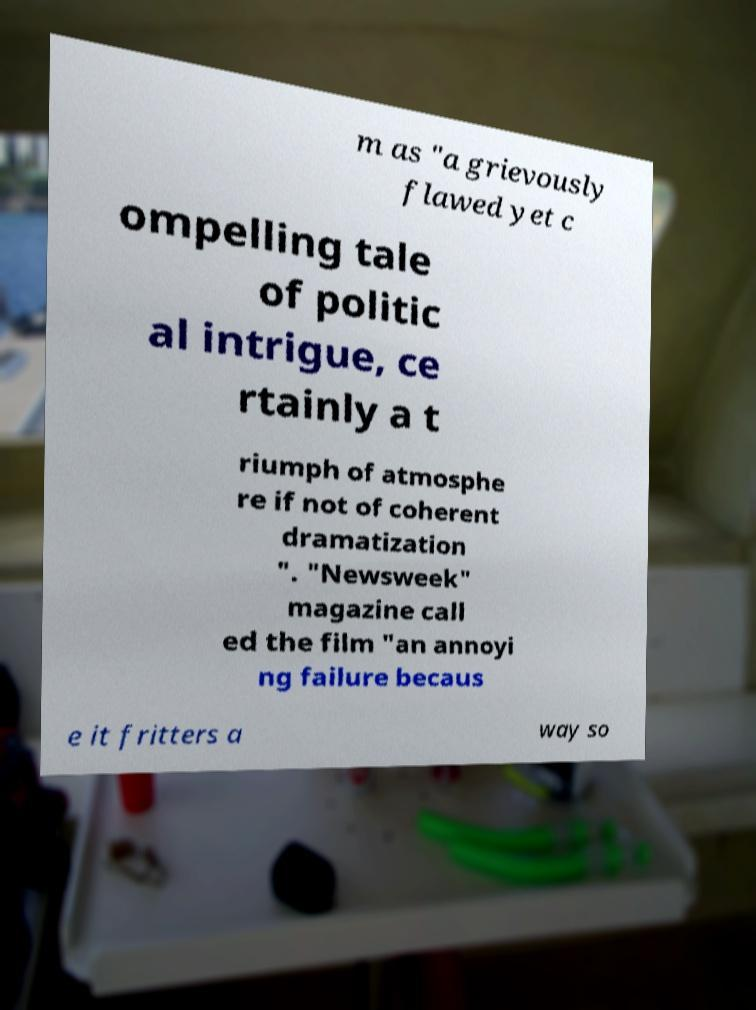What messages or text are displayed in this image? I need them in a readable, typed format. m as "a grievously flawed yet c ompelling tale of politic al intrigue, ce rtainly a t riumph of atmosphe re if not of coherent dramatization ". "Newsweek" magazine call ed the film "an annoyi ng failure becaus e it fritters a way so 